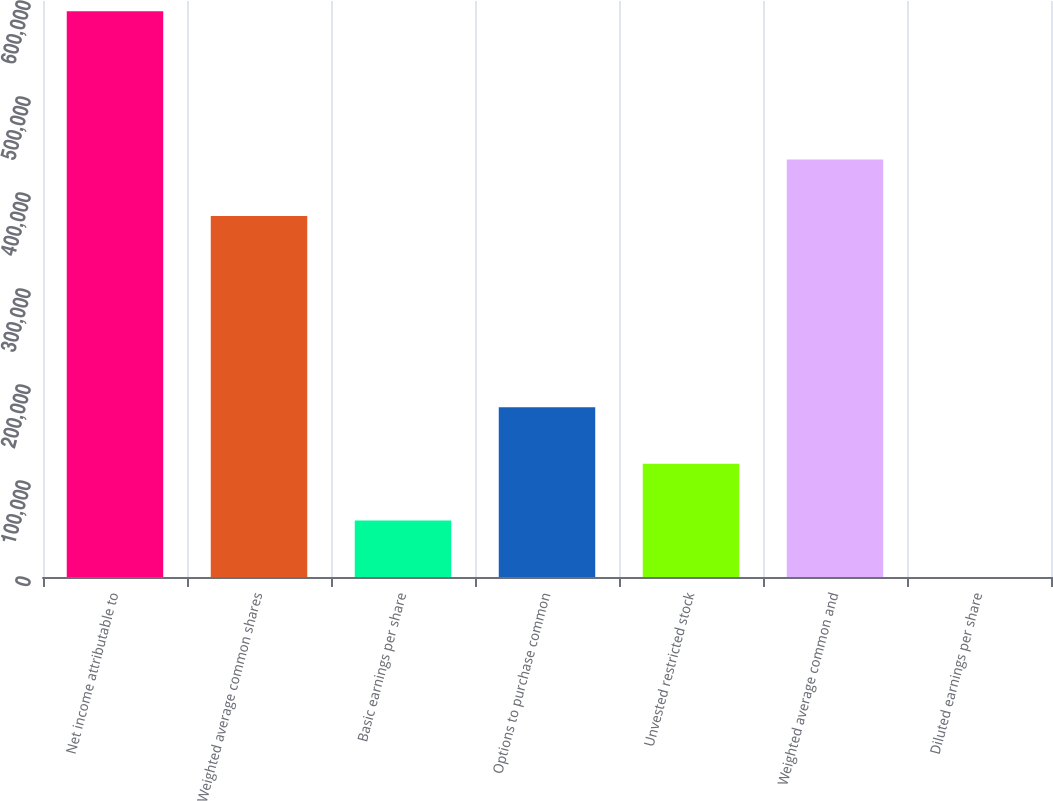Convert chart to OTSL. <chart><loc_0><loc_0><loc_500><loc_500><bar_chart><fcel>Net income attributable to<fcel>Weighted average common shares<fcel>Basic earnings per share<fcel>Options to purchase common<fcel>Unvested restricted stock<fcel>Weighted average common and<fcel>Diluted earnings per share<nl><fcel>589200<fcel>375961<fcel>58921.4<fcel>176761<fcel>117841<fcel>434881<fcel>1.56<nl></chart> 